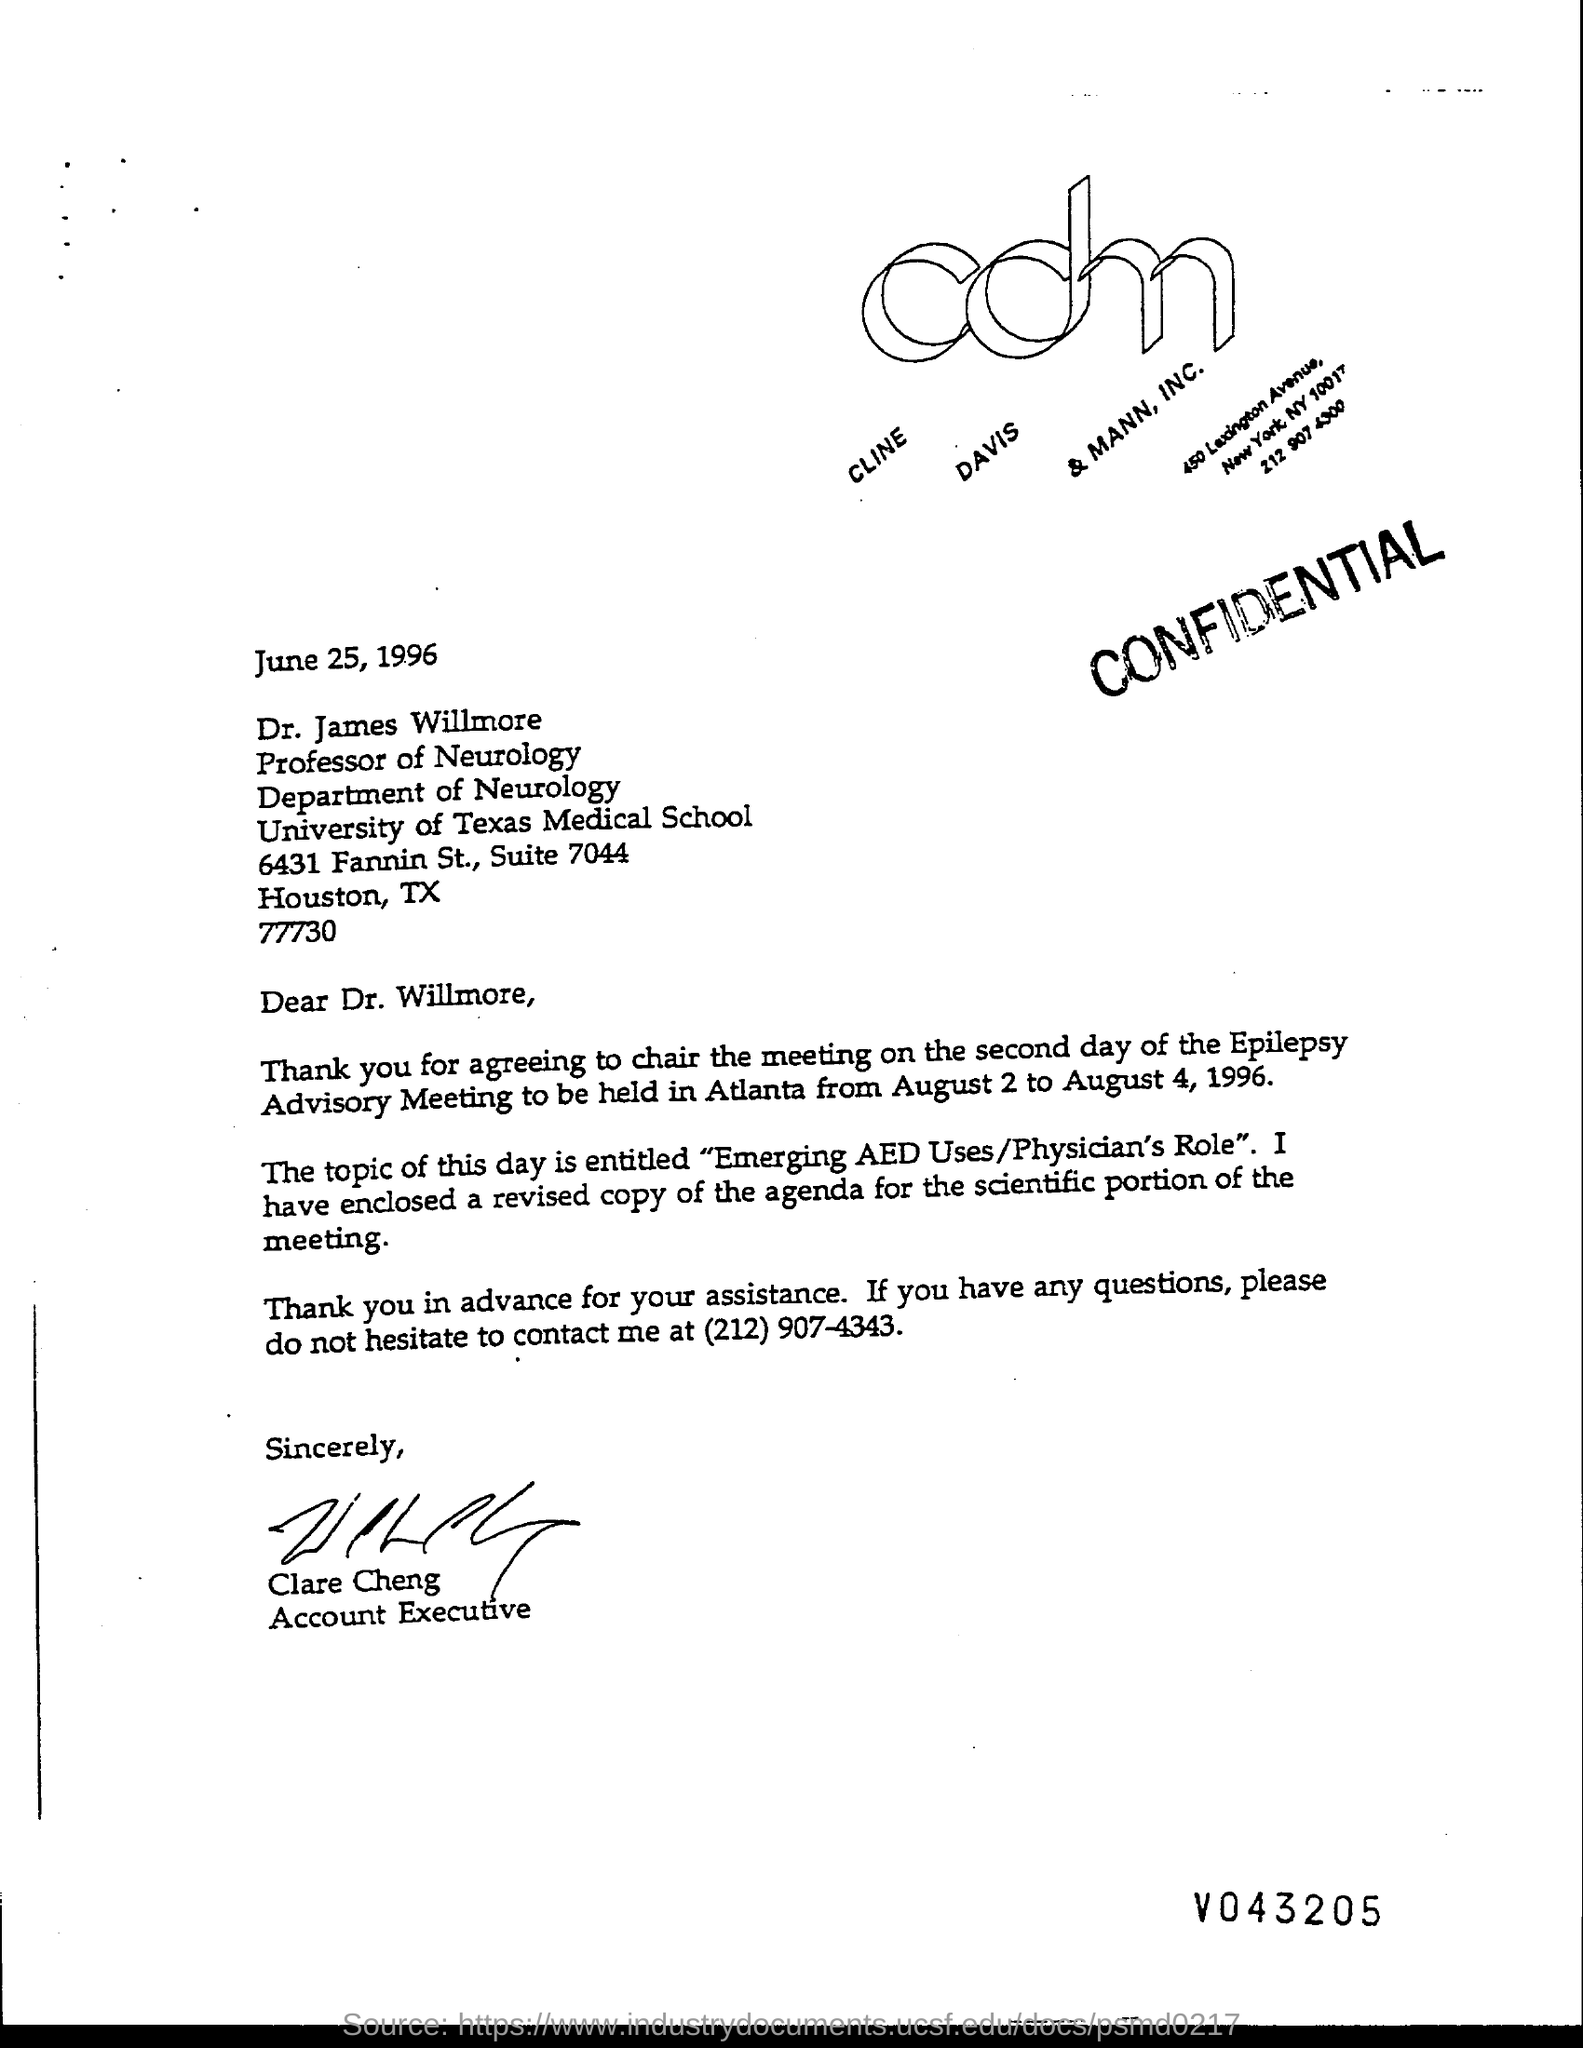Highlight a few significant elements in this photo. The writer of the letter is Clare Cheng. The issued date of this letter is June 25, 1996. Clare Cheng's designation is Account Executive. Dr. James Willmore holds the designation of Professor of Neurology. 